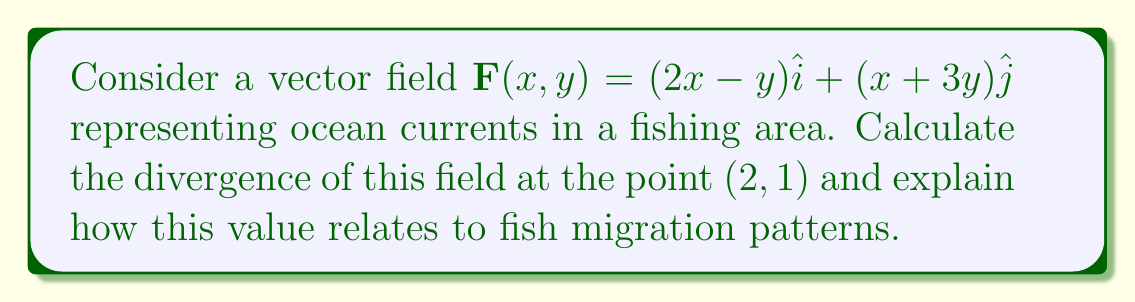Could you help me with this problem? 1) The divergence of a 2D vector field $\mathbf{F}(x,y) = P(x,y)\hat{i} + Q(x,y)\hat{j}$ is given by:

   $$\text{div}\mathbf{F} = \nabla \cdot \mathbf{F} = \frac{\partial P}{\partial x} + \frac{\partial Q}{\partial y}$$

2) In this case, $P(x,y) = 2x-y$ and $Q(x,y) = x+3y$

3) Calculate the partial derivatives:
   $$\frac{\partial P}{\partial x} = 2$$
   $$\frac{\partial Q}{\partial y} = 3$$

4) Sum the partial derivatives:
   $$\text{div}\mathbf{F} = \frac{\partial P}{\partial x} + \frac{\partial Q}{\partial y} = 2 + 3 = 5$$

5) The divergence is constant and positive throughout the field, including at point (2,1).

6) A positive divergence indicates that the vector field is expanding or spreading out at that point. In the context of ocean currents, this suggests a region where water is diverging or upwelling.

7) Upwelling areas are often rich in nutrients, attracting plankton and small fish, which in turn attract larger fish. This creates a productive fishing area and can influence fish migration patterns.
Answer: 5; positive divergence indicates upwelling, potentially attracting fish. 